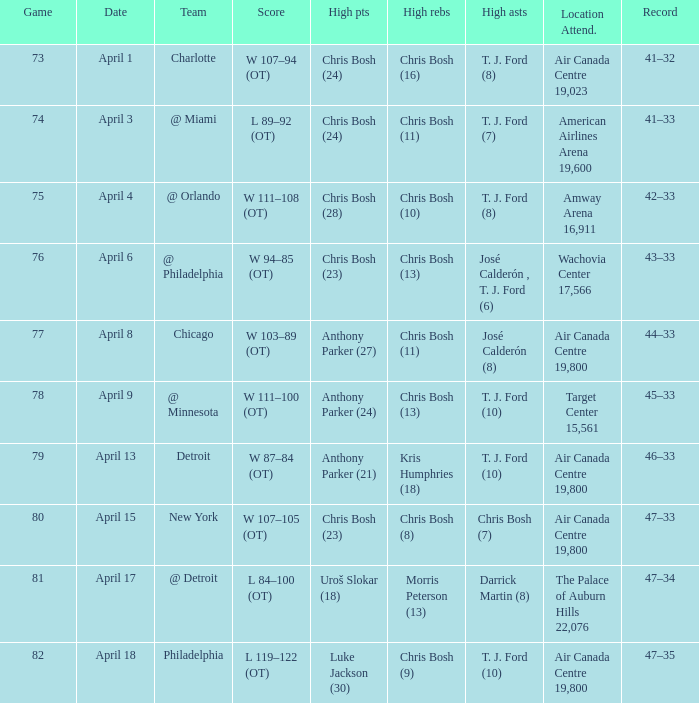What were the assists on April 8 in game less than 78? José Calderón (8). Write the full table. {'header': ['Game', 'Date', 'Team', 'Score', 'High pts', 'High rebs', 'High asts', 'Location Attend.', 'Record'], 'rows': [['73', 'April 1', 'Charlotte', 'W 107–94 (OT)', 'Chris Bosh (24)', 'Chris Bosh (16)', 'T. J. Ford (8)', 'Air Canada Centre 19,023', '41–32'], ['74', 'April 3', '@ Miami', 'L 89–92 (OT)', 'Chris Bosh (24)', 'Chris Bosh (11)', 'T. J. Ford (7)', 'American Airlines Arena 19,600', '41–33'], ['75', 'April 4', '@ Orlando', 'W 111–108 (OT)', 'Chris Bosh (28)', 'Chris Bosh (10)', 'T. J. Ford (8)', 'Amway Arena 16,911', '42–33'], ['76', 'April 6', '@ Philadelphia', 'W 94–85 (OT)', 'Chris Bosh (23)', 'Chris Bosh (13)', 'José Calderón , T. J. Ford (6)', 'Wachovia Center 17,566', '43–33'], ['77', 'April 8', 'Chicago', 'W 103–89 (OT)', 'Anthony Parker (27)', 'Chris Bosh (11)', 'José Calderón (8)', 'Air Canada Centre 19,800', '44–33'], ['78', 'April 9', '@ Minnesota', 'W 111–100 (OT)', 'Anthony Parker (24)', 'Chris Bosh (13)', 'T. J. Ford (10)', 'Target Center 15,561', '45–33'], ['79', 'April 13', 'Detroit', 'W 87–84 (OT)', 'Anthony Parker (21)', 'Kris Humphries (18)', 'T. J. Ford (10)', 'Air Canada Centre 19,800', '46–33'], ['80', 'April 15', 'New York', 'W 107–105 (OT)', 'Chris Bosh (23)', 'Chris Bosh (8)', 'Chris Bosh (7)', 'Air Canada Centre 19,800', '47–33'], ['81', 'April 17', '@ Detroit', 'L 84–100 (OT)', 'Uroš Slokar (18)', 'Morris Peterson (13)', 'Darrick Martin (8)', 'The Palace of Auburn Hills 22,076', '47–34'], ['82', 'April 18', 'Philadelphia', 'L 119–122 (OT)', 'Luke Jackson (30)', 'Chris Bosh (9)', 'T. J. Ford (10)', 'Air Canada Centre 19,800', '47–35']]} 